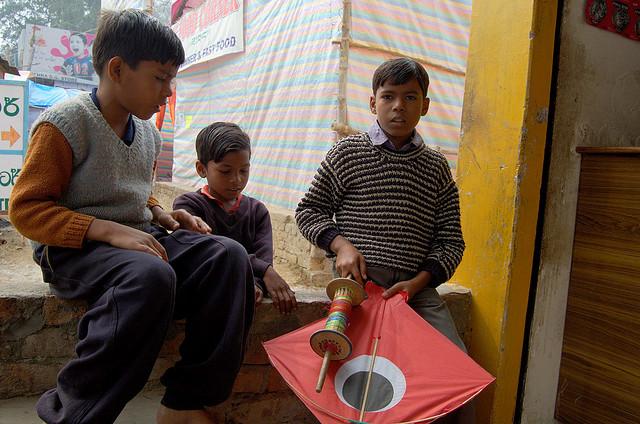Is it likely that the weather is very hot in the scene?
Answer briefly. No. Is there a party here?
Write a very short answer. No. Is it likely this is in the US?
Concise answer only. No. Are they selling cupcakes?
Concise answer only. No. What type of toy is the boy holding?
Short answer required. Kite. 